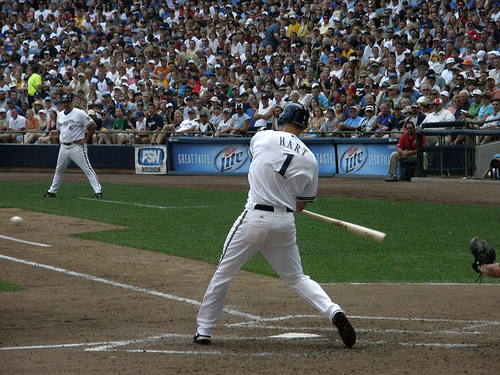Identify the text contained in this image. FSN GREAT TASTE Life Lite 6 1 TASTE HART 